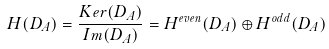Convert formula to latex. <formula><loc_0><loc_0><loc_500><loc_500>H ( D _ { A } ) & = \frac { K e r ( D _ { A } ) } { I m ( D _ { A } ) } = H ^ { e v e n } ( D _ { A } ) \oplus H ^ { o d d } ( D _ { A } )</formula> 